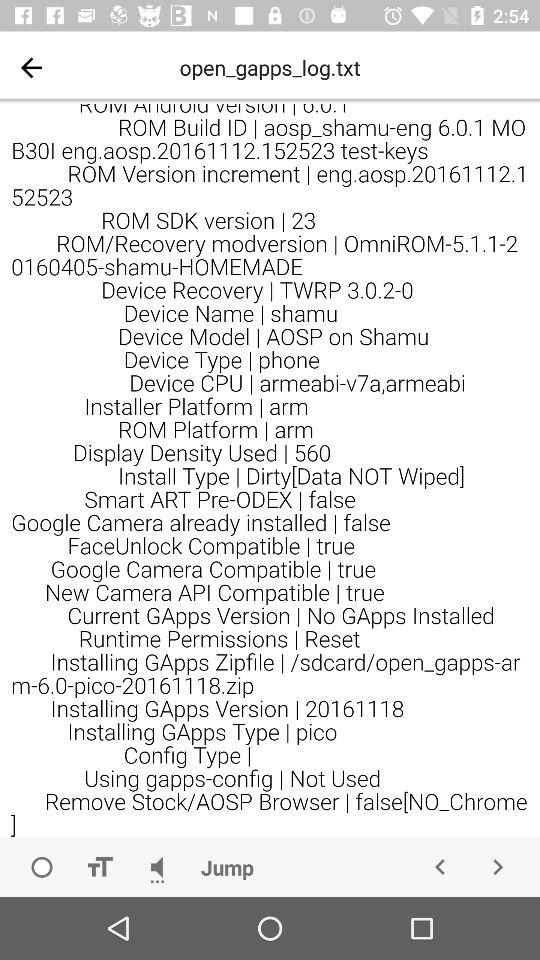What is the device model name? The device model name is "AOSP on Shamu". 